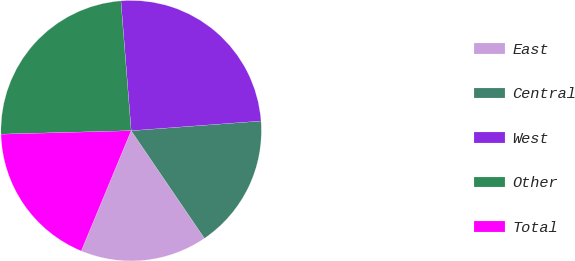Convert chart to OTSL. <chart><loc_0><loc_0><loc_500><loc_500><pie_chart><fcel>East<fcel>Central<fcel>West<fcel>Other<fcel>Total<nl><fcel>15.77%<fcel>16.67%<fcel>25.07%<fcel>24.17%<fcel>18.31%<nl></chart> 